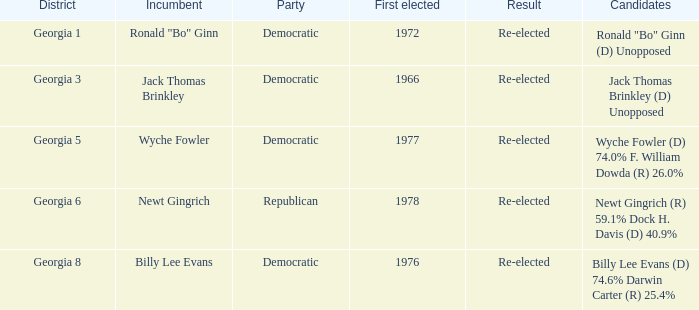How many parties were for candidates newt gingrich (r) 59.1% dock h. davis (d) 40.9%? 1.0. 